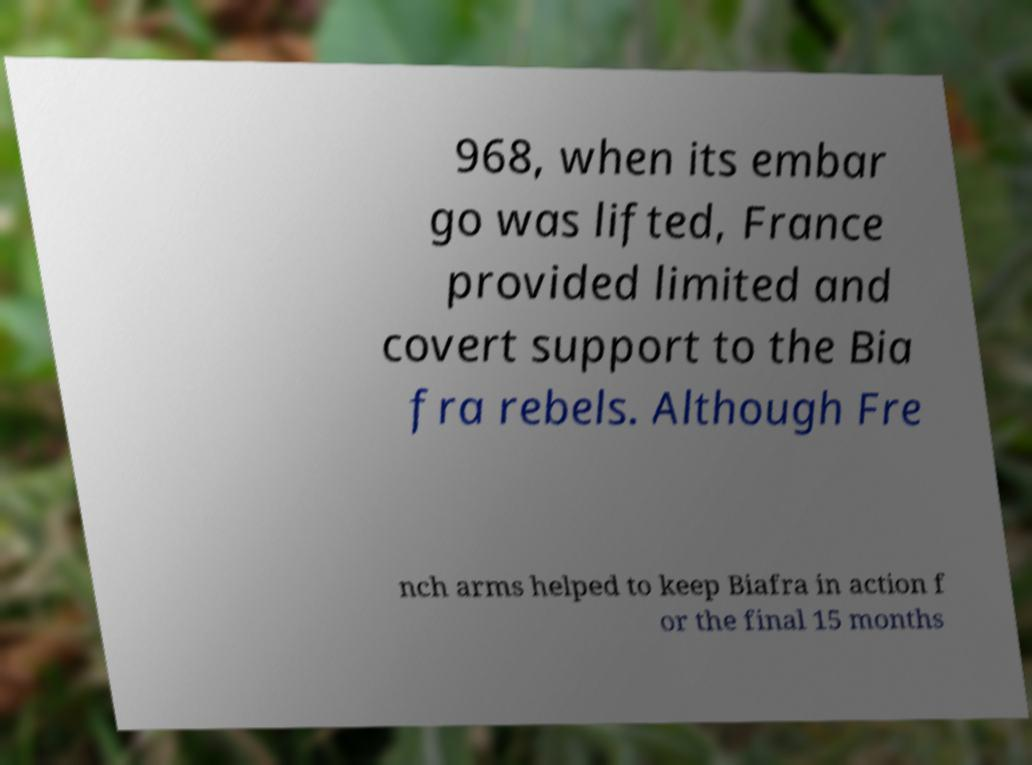What messages or text are displayed in this image? I need them in a readable, typed format. 968, when its embar go was lifted, France provided limited and covert support to the Bia fra rebels. Although Fre nch arms helped to keep Biafra in action f or the final 15 months 